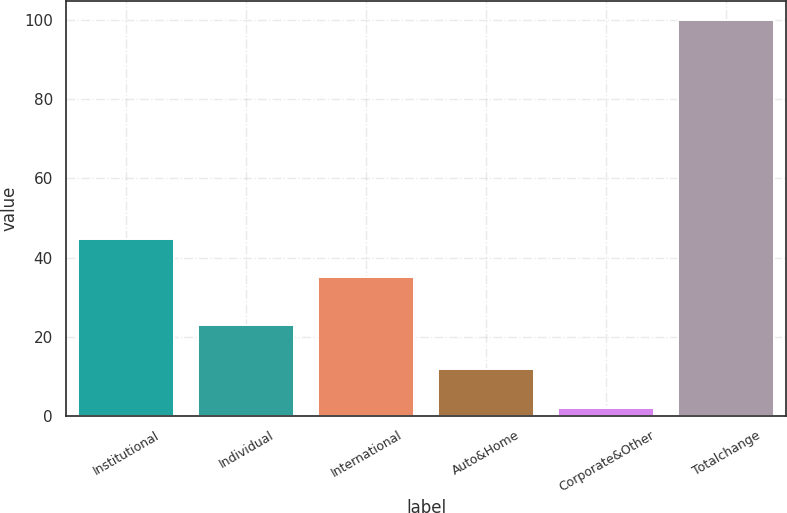Convert chart to OTSL. <chart><loc_0><loc_0><loc_500><loc_500><bar_chart><fcel>Institutional<fcel>Individual<fcel>International<fcel>Auto&Home<fcel>Corporate&Other<fcel>Totalchange<nl><fcel>44.8<fcel>23<fcel>35<fcel>11.8<fcel>2<fcel>100<nl></chart> 